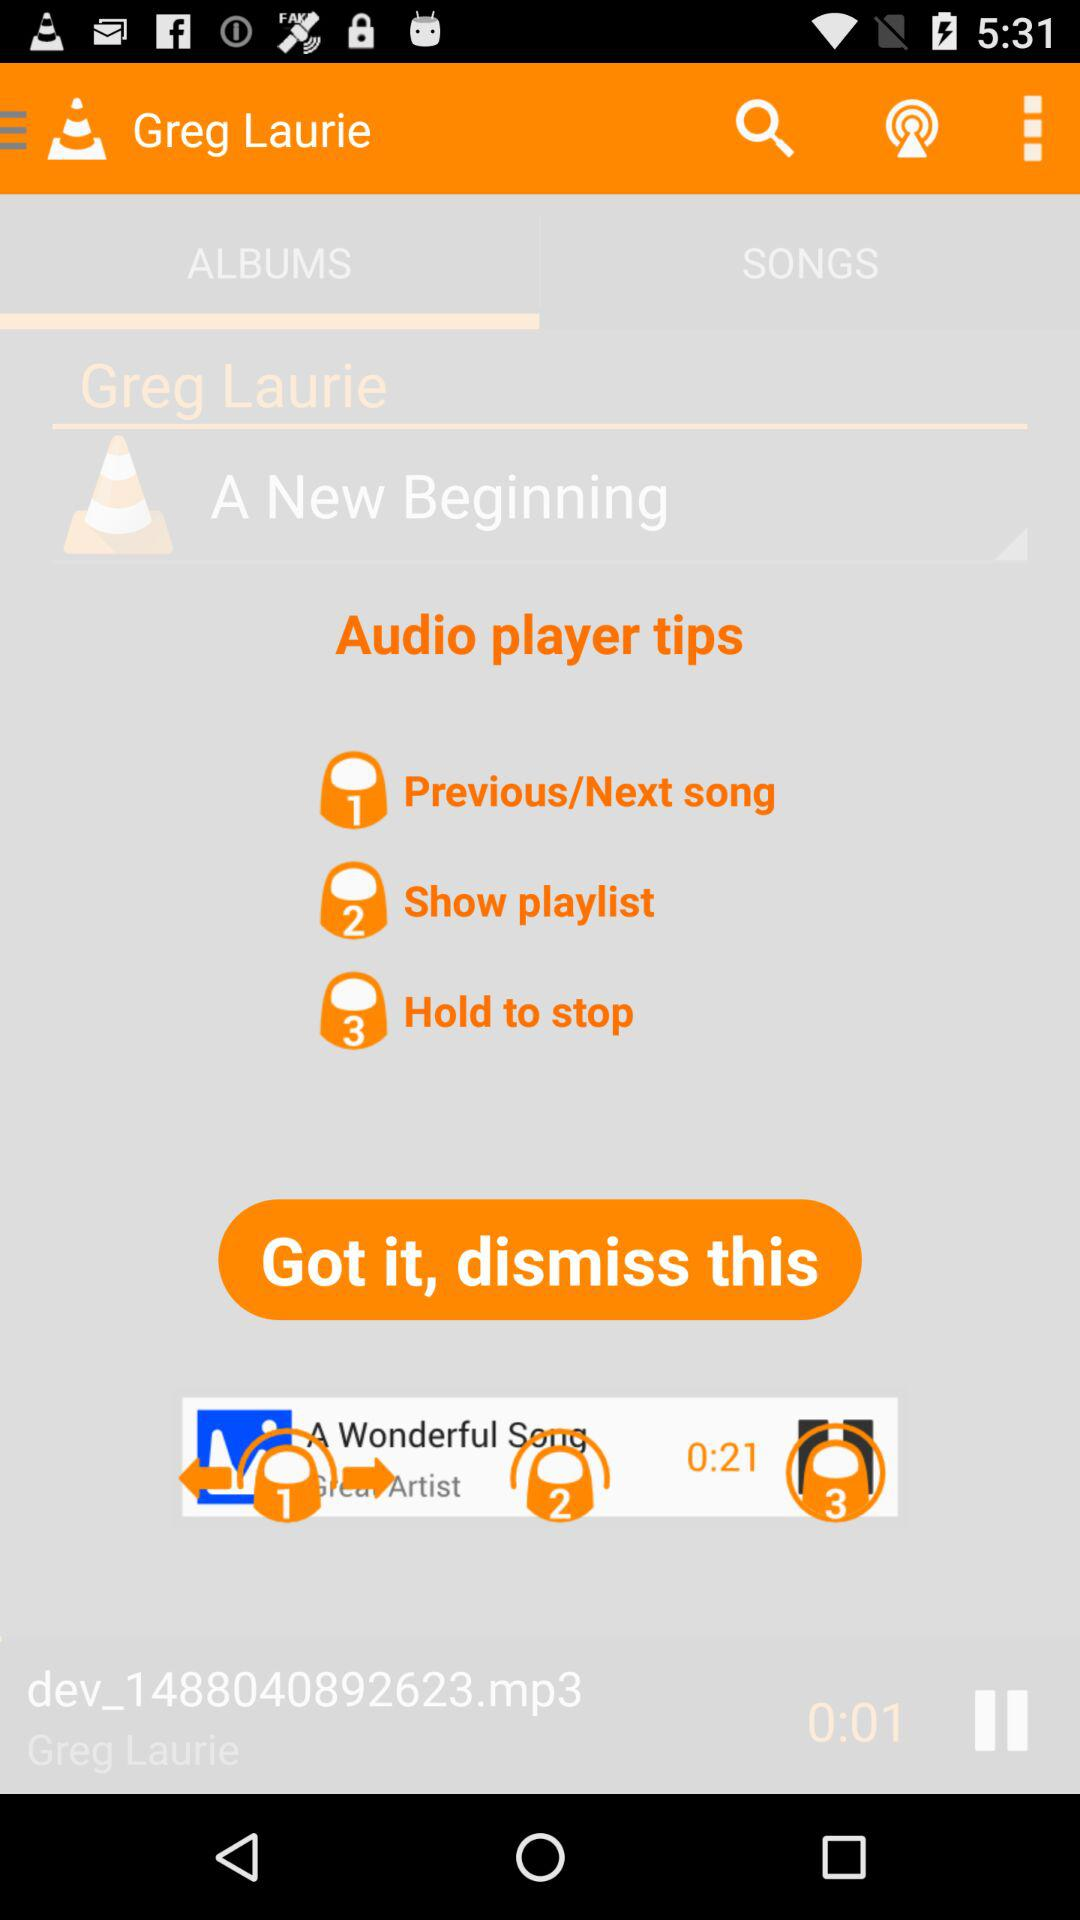What is the artist name? The artist name is Greg Laurie. 